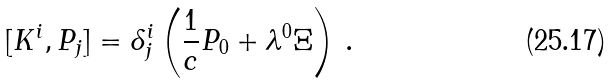Convert formula to latex. <formula><loc_0><loc_0><loc_500><loc_500>[ K ^ { i } , P _ { j } ] = \delta ^ { i } _ { j } \left ( \frac { 1 } { c } P _ { 0 } + \lambda ^ { 0 } \Xi \right ) \, .</formula> 